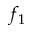<formula> <loc_0><loc_0><loc_500><loc_500>f _ { 1 }</formula> 